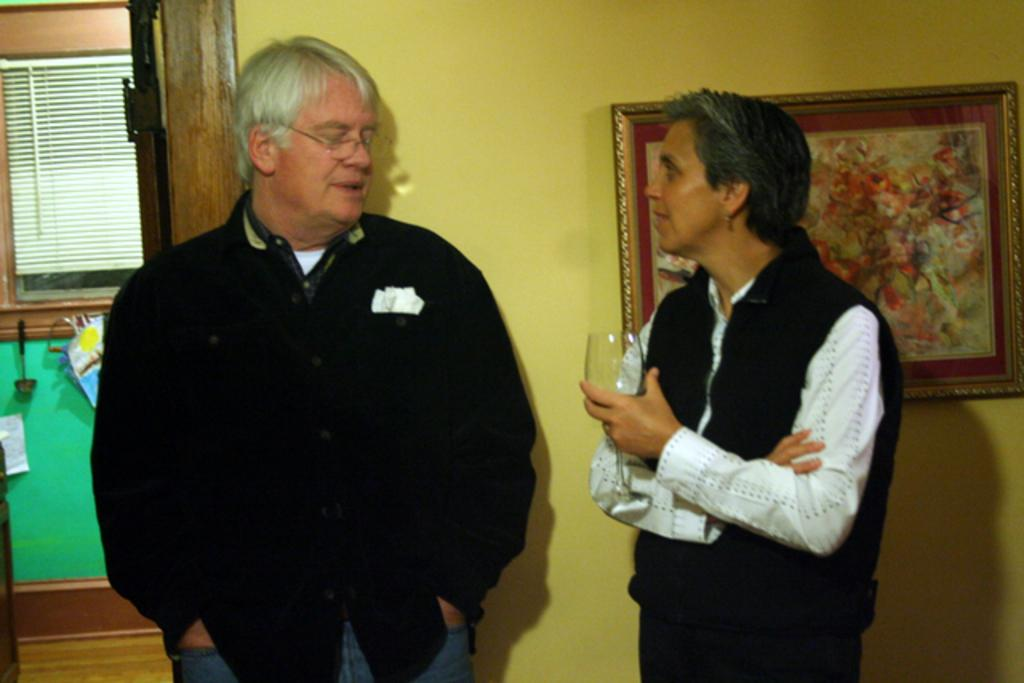How many people are in the image? There are two persons standing in the image. What is one of the persons holding? One of the persons is holding a glass. What can be seen in the background of the image? There is a wall visible in the background. What is on the wall in the image? There is a frame on the wall. What type of coil is visible on the sidewalk in the image? There is no sidewalk or coil present in the image. What is the tendency of the persons in the image to interact with each other? The provided facts do not give information about the interaction between the persons, so it is not possible to determine their tendency to interact. 